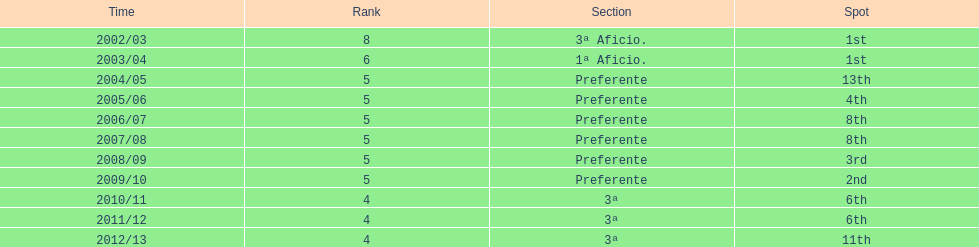Which division has the largest number of ranks? Preferente. 